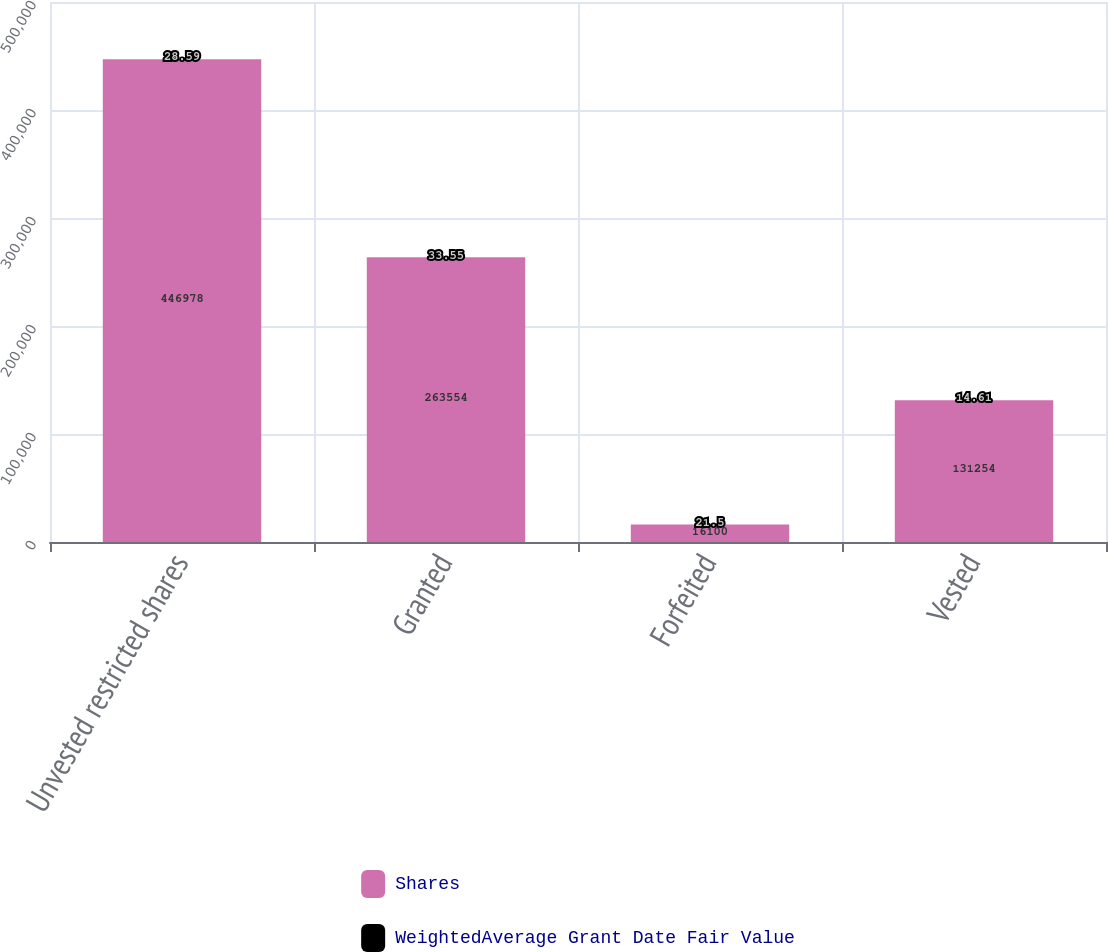Convert chart to OTSL. <chart><loc_0><loc_0><loc_500><loc_500><stacked_bar_chart><ecel><fcel>Unvested restricted shares<fcel>Granted<fcel>Forfeited<fcel>Vested<nl><fcel>Shares<fcel>446978<fcel>263554<fcel>16100<fcel>131254<nl><fcel>WeightedAverage Grant Date Fair Value<fcel>28.59<fcel>33.55<fcel>21.5<fcel>14.61<nl></chart> 